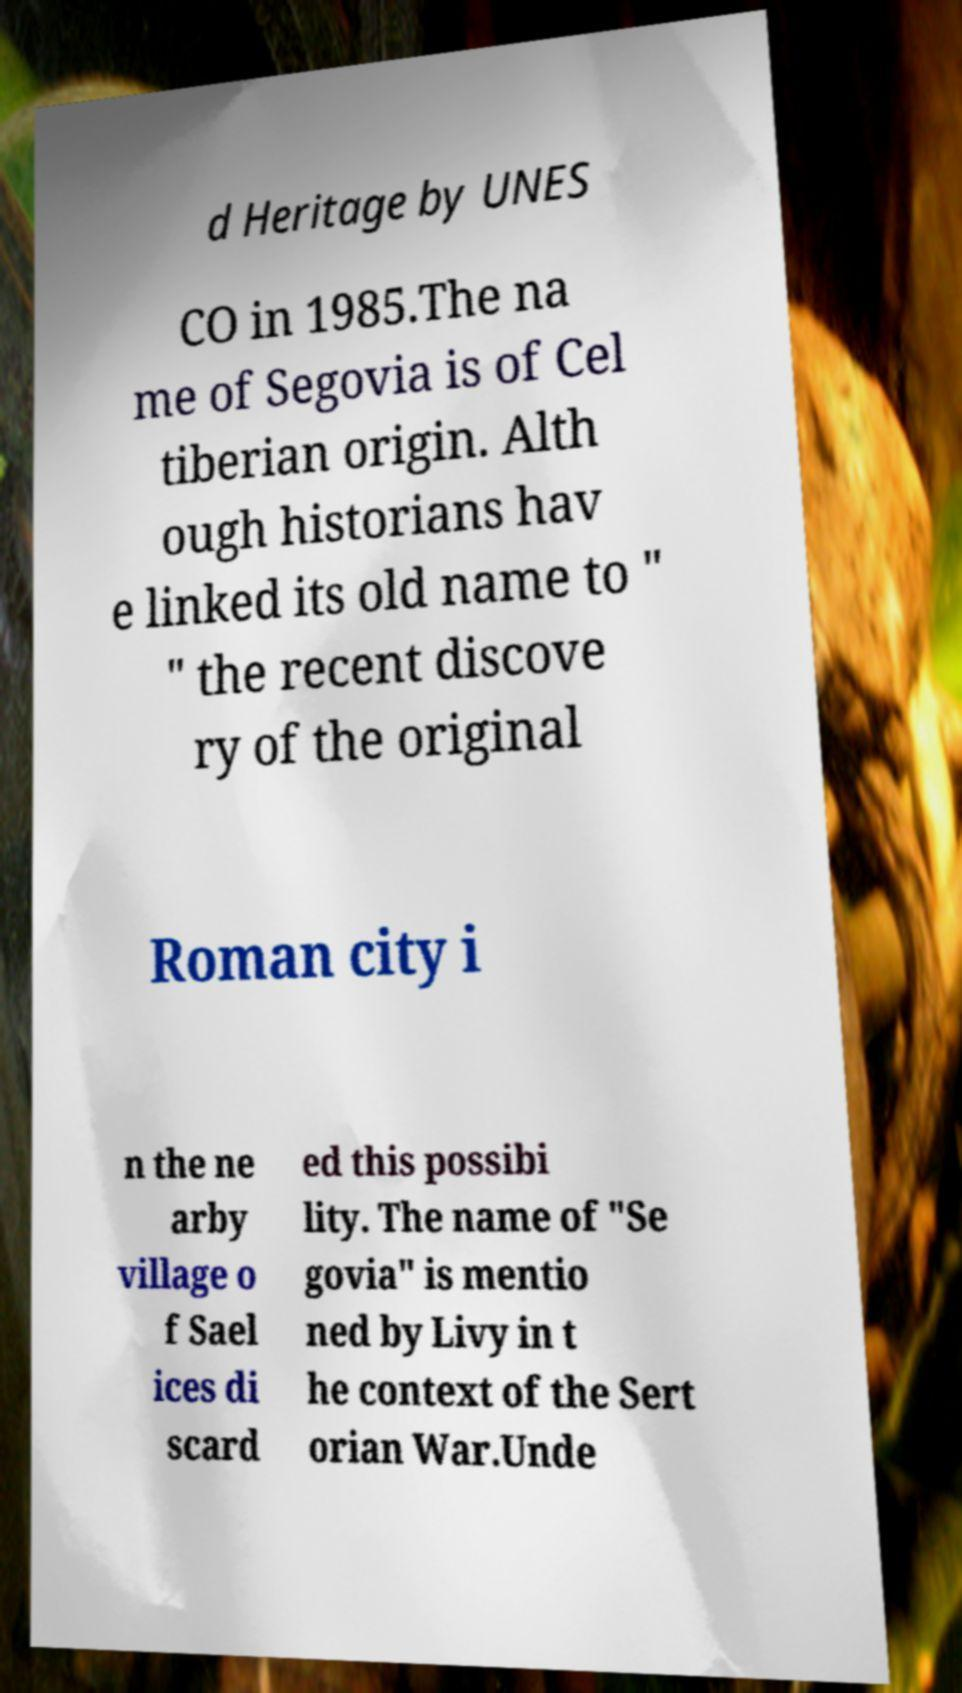Please identify and transcribe the text found in this image. d Heritage by UNES CO in 1985.The na me of Segovia is of Cel tiberian origin. Alth ough historians hav e linked its old name to " " the recent discove ry of the original Roman city i n the ne arby village o f Sael ices di scard ed this possibi lity. The name of "Se govia" is mentio ned by Livy in t he context of the Sert orian War.Unde 